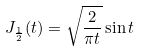<formula> <loc_0><loc_0><loc_500><loc_500>J _ { \frac { 1 } { 2 } } ( t ) = \sqrt { \frac { 2 } { \pi t } } \sin t</formula> 